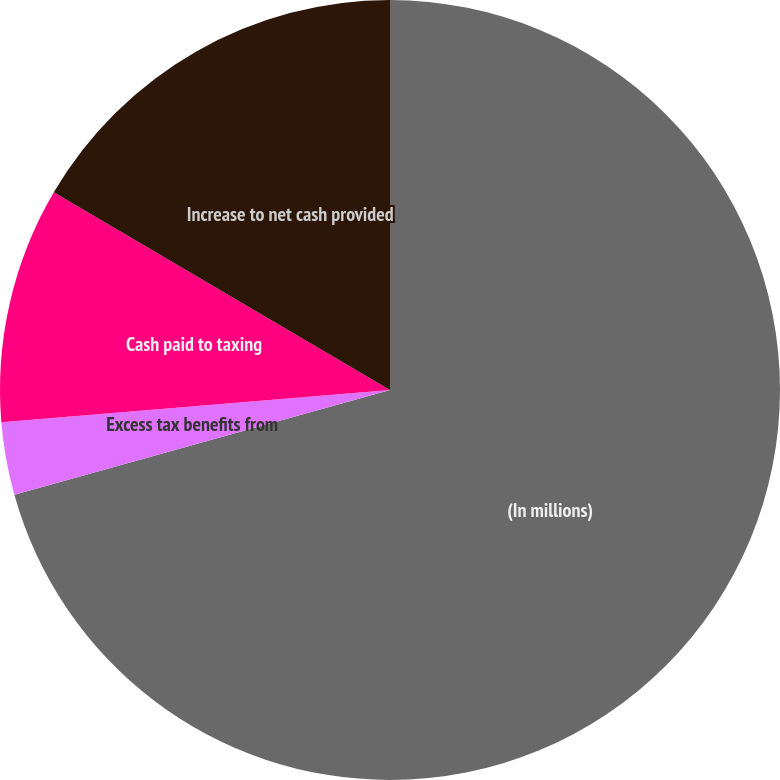Convert chart to OTSL. <chart><loc_0><loc_0><loc_500><loc_500><pie_chart><fcel>(In millions)<fcel>Excess tax benefits from<fcel>Cash paid to taxing<fcel>Increase to net cash provided<nl><fcel>70.66%<fcel>3.01%<fcel>9.78%<fcel>16.54%<nl></chart> 